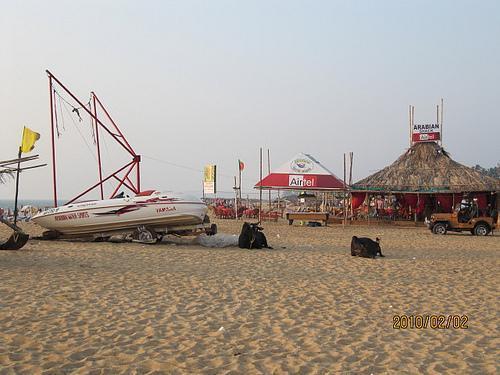How many cars are there?
Give a very brief answer. 1. How many boats are there?
Give a very brief answer. 1. 